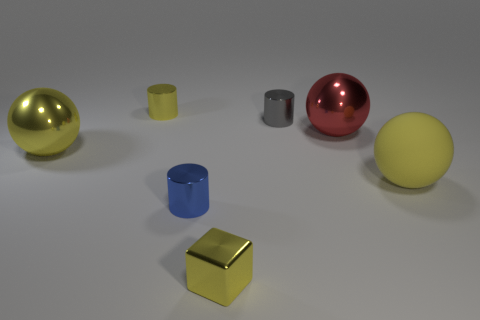There is a blue shiny cylinder in front of the tiny object behind the gray metallic cylinder; how many large metal things are in front of it?
Your response must be concise. 0. Is the number of blue objects that are on the right side of the blue object less than the number of small red cylinders?
Your answer should be very brief. No. Does the small metal cube have the same color as the large rubber ball?
Keep it short and to the point. Yes. There is a gray metallic object that is the same shape as the blue metal object; what size is it?
Provide a short and direct response. Small. What number of other yellow blocks have the same material as the small yellow cube?
Your answer should be very brief. 0. Are the cylinder that is on the right side of the blue object and the tiny yellow cube made of the same material?
Offer a terse response. Yes. Is the number of tiny shiny cylinders that are in front of the tiny blue shiny object the same as the number of green matte spheres?
Give a very brief answer. Yes. What size is the gray thing?
Offer a very short reply. Small. How many rubber balls have the same color as the large matte object?
Make the answer very short. 0. Is the matte object the same size as the gray metallic thing?
Keep it short and to the point. No. 